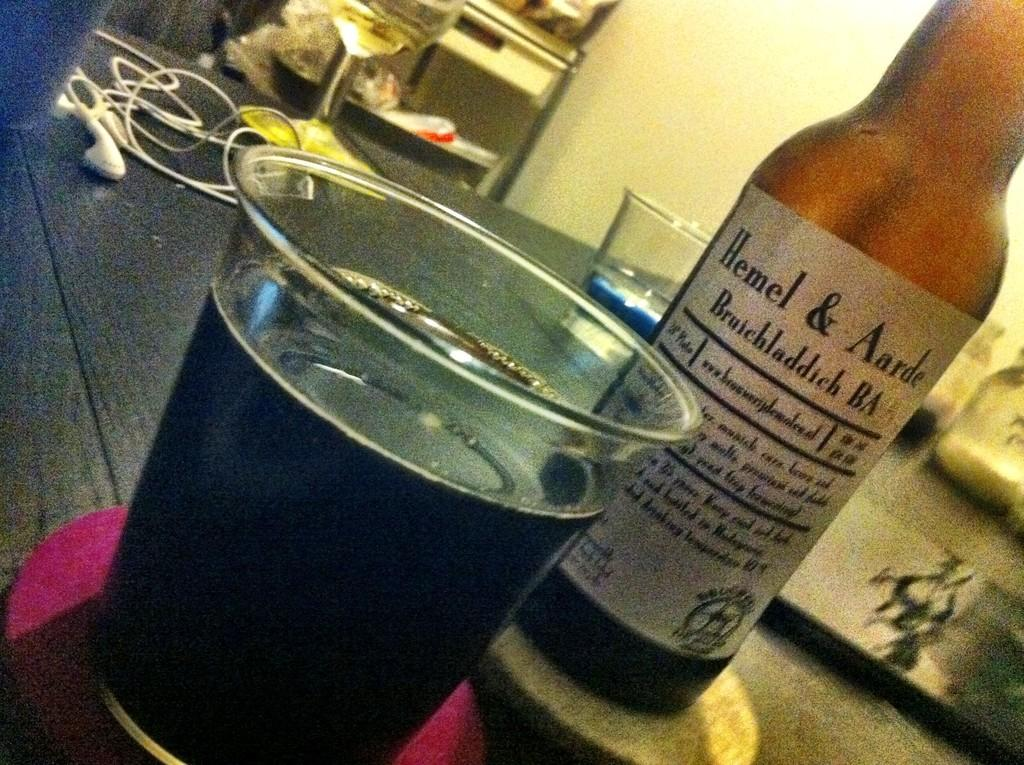<image>
Give a short and clear explanation of the subsequent image. Bottle with a white label saying Hemel & Aarde next to a cup of beer. 